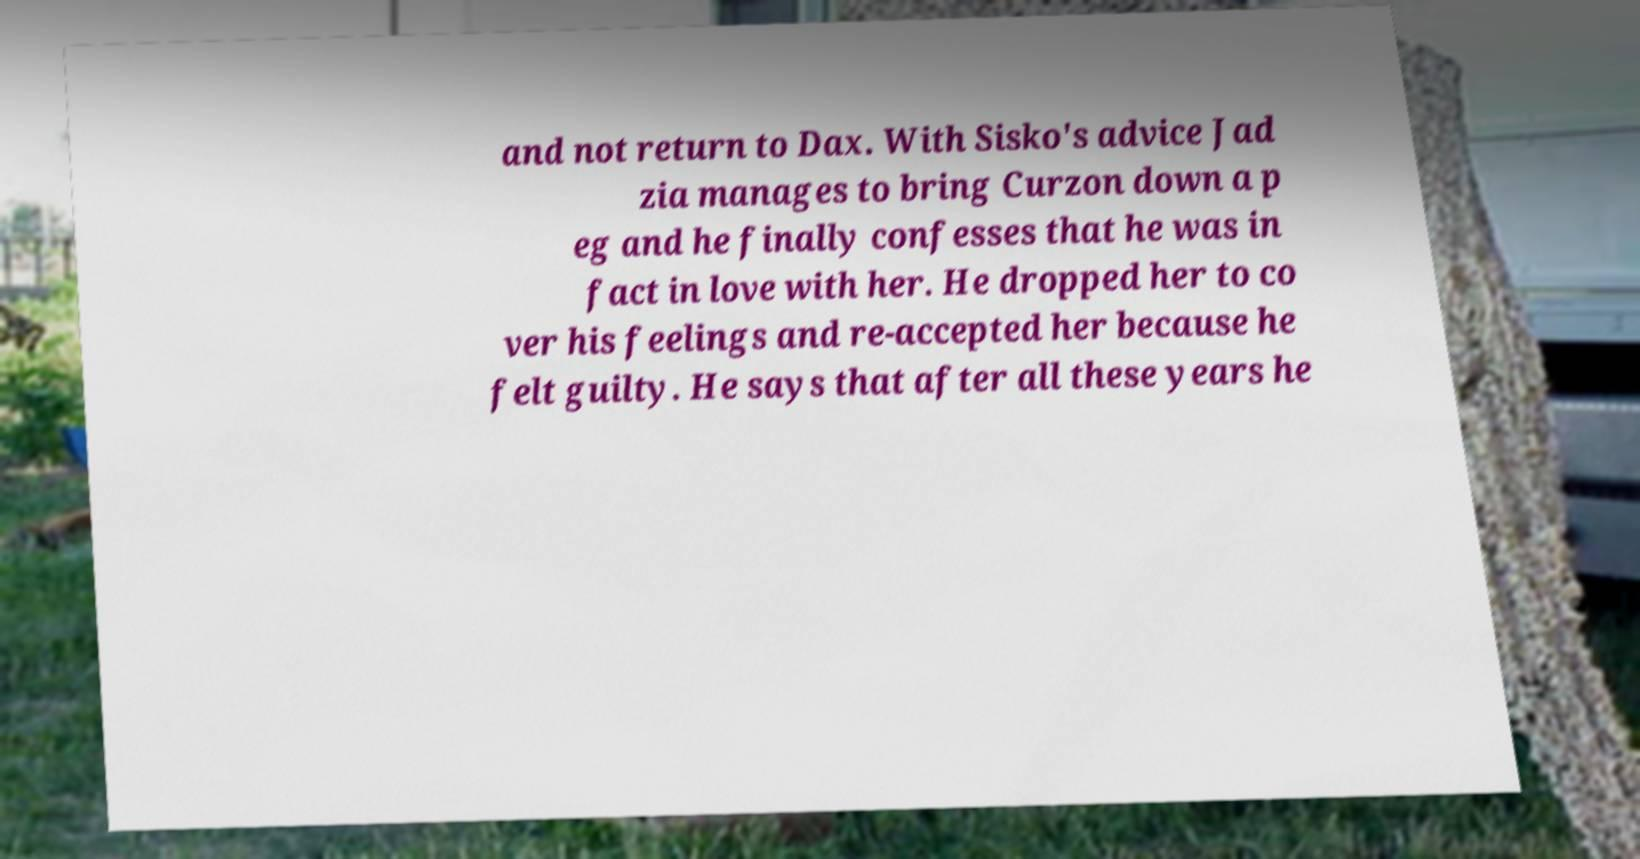Please identify and transcribe the text found in this image. and not return to Dax. With Sisko's advice Jad zia manages to bring Curzon down a p eg and he finally confesses that he was in fact in love with her. He dropped her to co ver his feelings and re-accepted her because he felt guilty. He says that after all these years he 